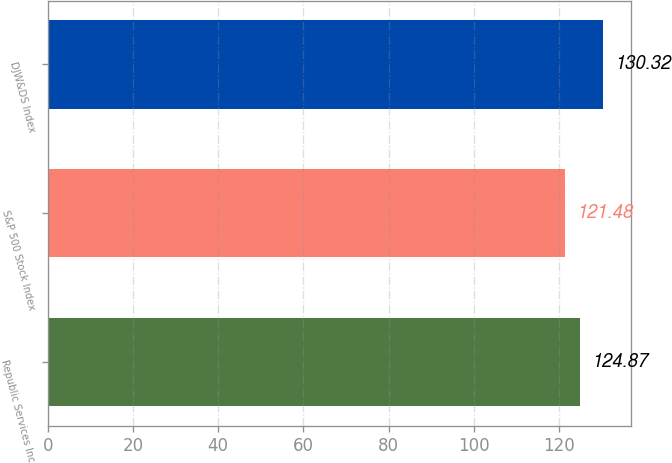Convert chart to OTSL. <chart><loc_0><loc_0><loc_500><loc_500><bar_chart><fcel>Republic Services Inc<fcel>S&P 500 Stock Index<fcel>DJW&DS Index<nl><fcel>124.87<fcel>121.48<fcel>130.32<nl></chart> 